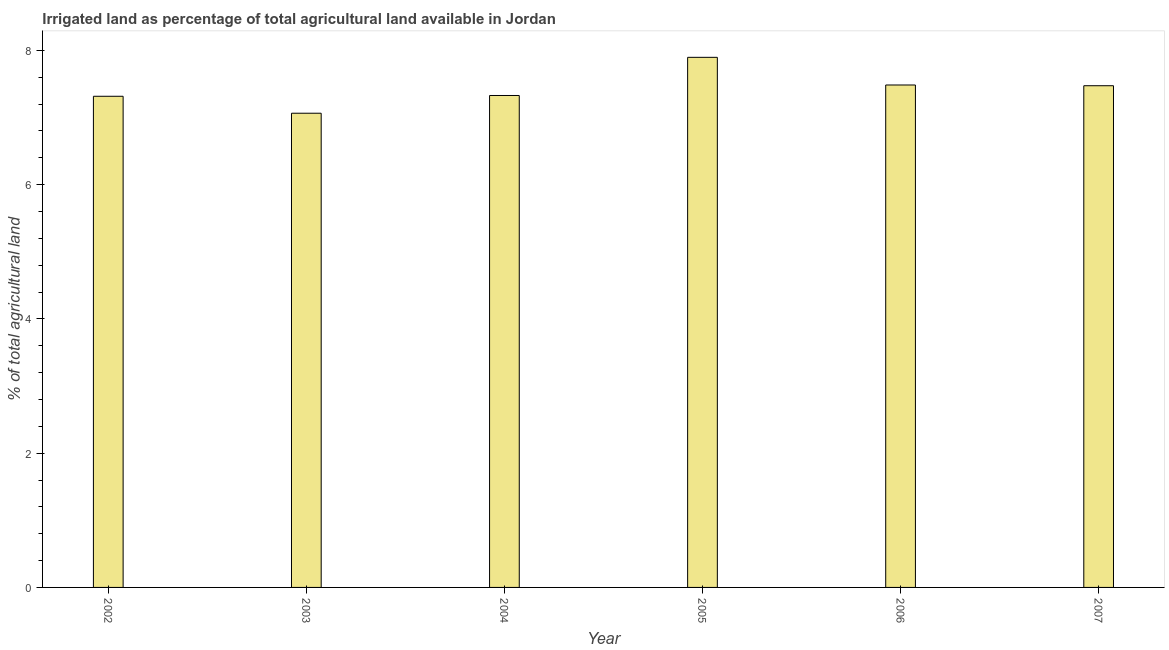Does the graph contain grids?
Offer a terse response. No. What is the title of the graph?
Give a very brief answer. Irrigated land as percentage of total agricultural land available in Jordan. What is the label or title of the X-axis?
Your response must be concise. Year. What is the label or title of the Y-axis?
Your response must be concise. % of total agricultural land. What is the percentage of agricultural irrigated land in 2002?
Offer a very short reply. 7.32. Across all years, what is the maximum percentage of agricultural irrigated land?
Make the answer very short. 7.9. Across all years, what is the minimum percentage of agricultural irrigated land?
Provide a succinct answer. 7.06. In which year was the percentage of agricultural irrigated land maximum?
Give a very brief answer. 2005. In which year was the percentage of agricultural irrigated land minimum?
Offer a very short reply. 2003. What is the sum of the percentage of agricultural irrigated land?
Make the answer very short. 44.57. What is the difference between the percentage of agricultural irrigated land in 2003 and 2006?
Make the answer very short. -0.42. What is the average percentage of agricultural irrigated land per year?
Make the answer very short. 7.43. What is the median percentage of agricultural irrigated land?
Make the answer very short. 7.4. In how many years, is the percentage of agricultural irrigated land greater than 6.8 %?
Offer a very short reply. 6. Do a majority of the years between 2006 and 2005 (inclusive) have percentage of agricultural irrigated land greater than 6 %?
Offer a terse response. No. What is the ratio of the percentage of agricultural irrigated land in 2003 to that in 2007?
Give a very brief answer. 0.94. Is the difference between the percentage of agricultural irrigated land in 2004 and 2005 greater than the difference between any two years?
Provide a short and direct response. No. What is the difference between the highest and the second highest percentage of agricultural irrigated land?
Provide a succinct answer. 0.41. Is the sum of the percentage of agricultural irrigated land in 2003 and 2006 greater than the maximum percentage of agricultural irrigated land across all years?
Your answer should be very brief. Yes. What is the difference between the highest and the lowest percentage of agricultural irrigated land?
Provide a succinct answer. 0.83. Are all the bars in the graph horizontal?
Make the answer very short. No. What is the difference between two consecutive major ticks on the Y-axis?
Give a very brief answer. 2. Are the values on the major ticks of Y-axis written in scientific E-notation?
Keep it short and to the point. No. What is the % of total agricultural land of 2002?
Ensure brevity in your answer.  7.32. What is the % of total agricultural land of 2003?
Provide a short and direct response. 7.06. What is the % of total agricultural land in 2004?
Provide a short and direct response. 7.33. What is the % of total agricultural land in 2005?
Your answer should be compact. 7.9. What is the % of total agricultural land in 2006?
Make the answer very short. 7.49. What is the % of total agricultural land of 2007?
Make the answer very short. 7.47. What is the difference between the % of total agricultural land in 2002 and 2003?
Offer a very short reply. 0.25. What is the difference between the % of total agricultural land in 2002 and 2004?
Your answer should be very brief. -0.01. What is the difference between the % of total agricultural land in 2002 and 2005?
Offer a terse response. -0.58. What is the difference between the % of total agricultural land in 2002 and 2006?
Offer a terse response. -0.17. What is the difference between the % of total agricultural land in 2002 and 2007?
Offer a very short reply. -0.16. What is the difference between the % of total agricultural land in 2003 and 2004?
Give a very brief answer. -0.26. What is the difference between the % of total agricultural land in 2003 and 2005?
Provide a succinct answer. -0.83. What is the difference between the % of total agricultural land in 2003 and 2006?
Ensure brevity in your answer.  -0.42. What is the difference between the % of total agricultural land in 2003 and 2007?
Ensure brevity in your answer.  -0.41. What is the difference between the % of total agricultural land in 2004 and 2005?
Give a very brief answer. -0.57. What is the difference between the % of total agricultural land in 2004 and 2006?
Your answer should be compact. -0.16. What is the difference between the % of total agricultural land in 2004 and 2007?
Your answer should be compact. -0.15. What is the difference between the % of total agricultural land in 2005 and 2006?
Provide a succinct answer. 0.41. What is the difference between the % of total agricultural land in 2005 and 2007?
Make the answer very short. 0.42. What is the difference between the % of total agricultural land in 2006 and 2007?
Give a very brief answer. 0.01. What is the ratio of the % of total agricultural land in 2002 to that in 2003?
Offer a terse response. 1.04. What is the ratio of the % of total agricultural land in 2002 to that in 2004?
Offer a very short reply. 1. What is the ratio of the % of total agricultural land in 2002 to that in 2005?
Provide a succinct answer. 0.93. What is the ratio of the % of total agricultural land in 2002 to that in 2007?
Provide a short and direct response. 0.98. What is the ratio of the % of total agricultural land in 2003 to that in 2005?
Offer a very short reply. 0.9. What is the ratio of the % of total agricultural land in 2003 to that in 2006?
Provide a short and direct response. 0.94. What is the ratio of the % of total agricultural land in 2003 to that in 2007?
Provide a short and direct response. 0.94. What is the ratio of the % of total agricultural land in 2004 to that in 2005?
Provide a short and direct response. 0.93. What is the ratio of the % of total agricultural land in 2005 to that in 2006?
Provide a succinct answer. 1.05. What is the ratio of the % of total agricultural land in 2005 to that in 2007?
Offer a very short reply. 1.06. What is the ratio of the % of total agricultural land in 2006 to that in 2007?
Ensure brevity in your answer.  1. 